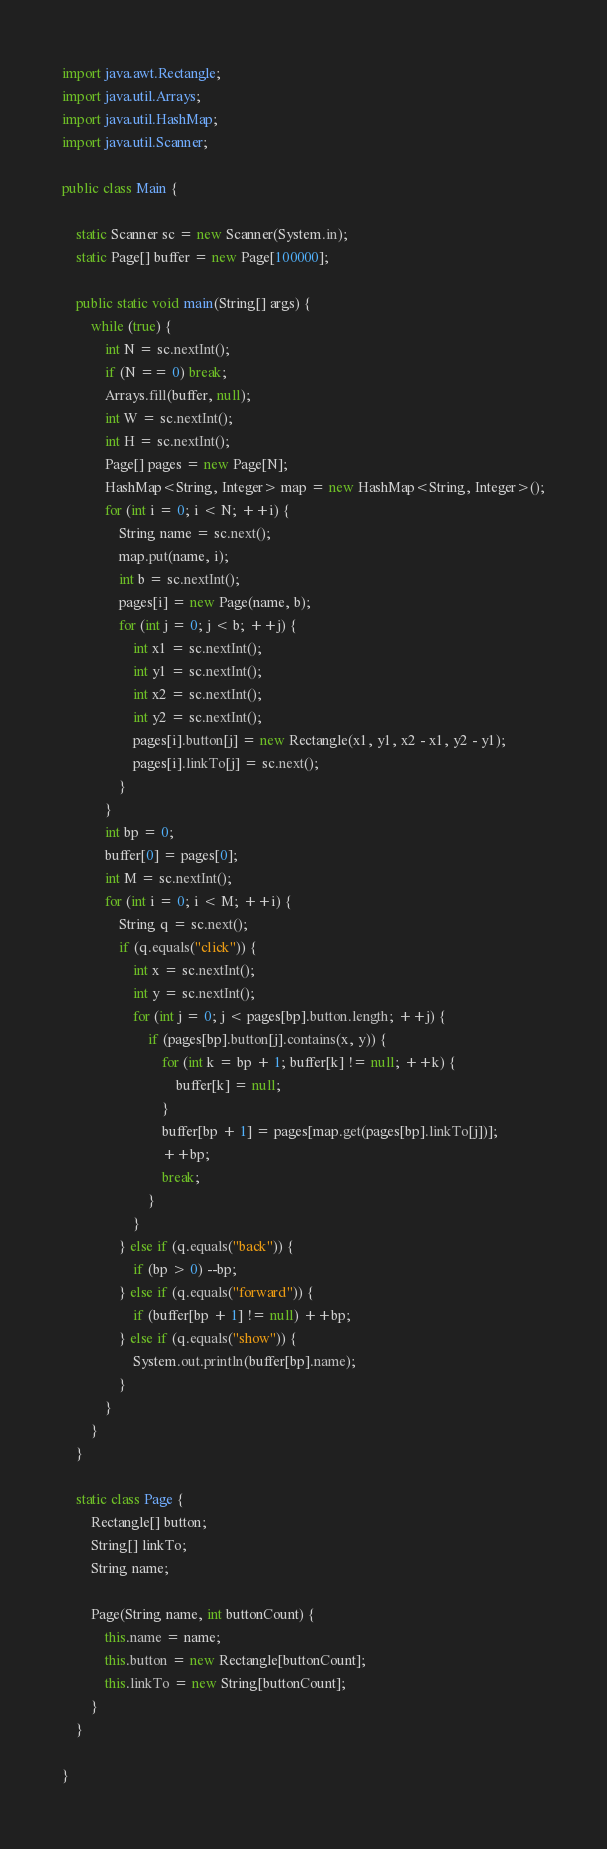Convert code to text. <code><loc_0><loc_0><loc_500><loc_500><_Java_>import java.awt.Rectangle;
import java.util.Arrays;
import java.util.HashMap;
import java.util.Scanner;

public class Main {

	static Scanner sc = new Scanner(System.in);
	static Page[] buffer = new Page[100000];

	public static void main(String[] args) {
		while (true) {
			int N = sc.nextInt();
			if (N == 0) break;
			Arrays.fill(buffer, null);
			int W = sc.nextInt();
			int H = sc.nextInt();
			Page[] pages = new Page[N];
			HashMap<String, Integer> map = new HashMap<String, Integer>();
			for (int i = 0; i < N; ++i) {
				String name = sc.next();
				map.put(name, i);
				int b = sc.nextInt();
				pages[i] = new Page(name, b);
				for (int j = 0; j < b; ++j) {
					int x1 = sc.nextInt();
					int y1 = sc.nextInt();
					int x2 = sc.nextInt();
					int y2 = sc.nextInt();
					pages[i].button[j] = new Rectangle(x1, y1, x2 - x1, y2 - y1);
					pages[i].linkTo[j] = sc.next();
				}
			}
			int bp = 0;
			buffer[0] = pages[0];
			int M = sc.nextInt();
			for (int i = 0; i < M; ++i) {
				String q = sc.next();
				if (q.equals("click")) {
					int x = sc.nextInt();
					int y = sc.nextInt();
					for (int j = 0; j < pages[bp].button.length; ++j) {
						if (pages[bp].button[j].contains(x, y)) {
							for (int k = bp + 1; buffer[k] != null; ++k) {
								buffer[k] = null;
							}
							buffer[bp + 1] = pages[map.get(pages[bp].linkTo[j])];
							++bp;
							break;
						}
					}
				} else if (q.equals("back")) {
					if (bp > 0) --bp;
				} else if (q.equals("forward")) {
					if (buffer[bp + 1] != null) ++bp;
				} else if (q.equals("show")) {
					System.out.println(buffer[bp].name);
				}
			}
		}
	}

	static class Page {
		Rectangle[] button;
		String[] linkTo;
		String name;

		Page(String name, int buttonCount) {
			this.name = name;
			this.button = new Rectangle[buttonCount];
			this.linkTo = new String[buttonCount];
		}
	}

}</code> 